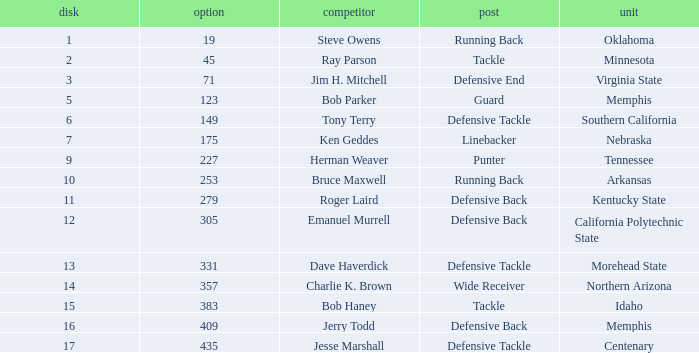What is the average pick of player jim h. mitchell? 71.0. 